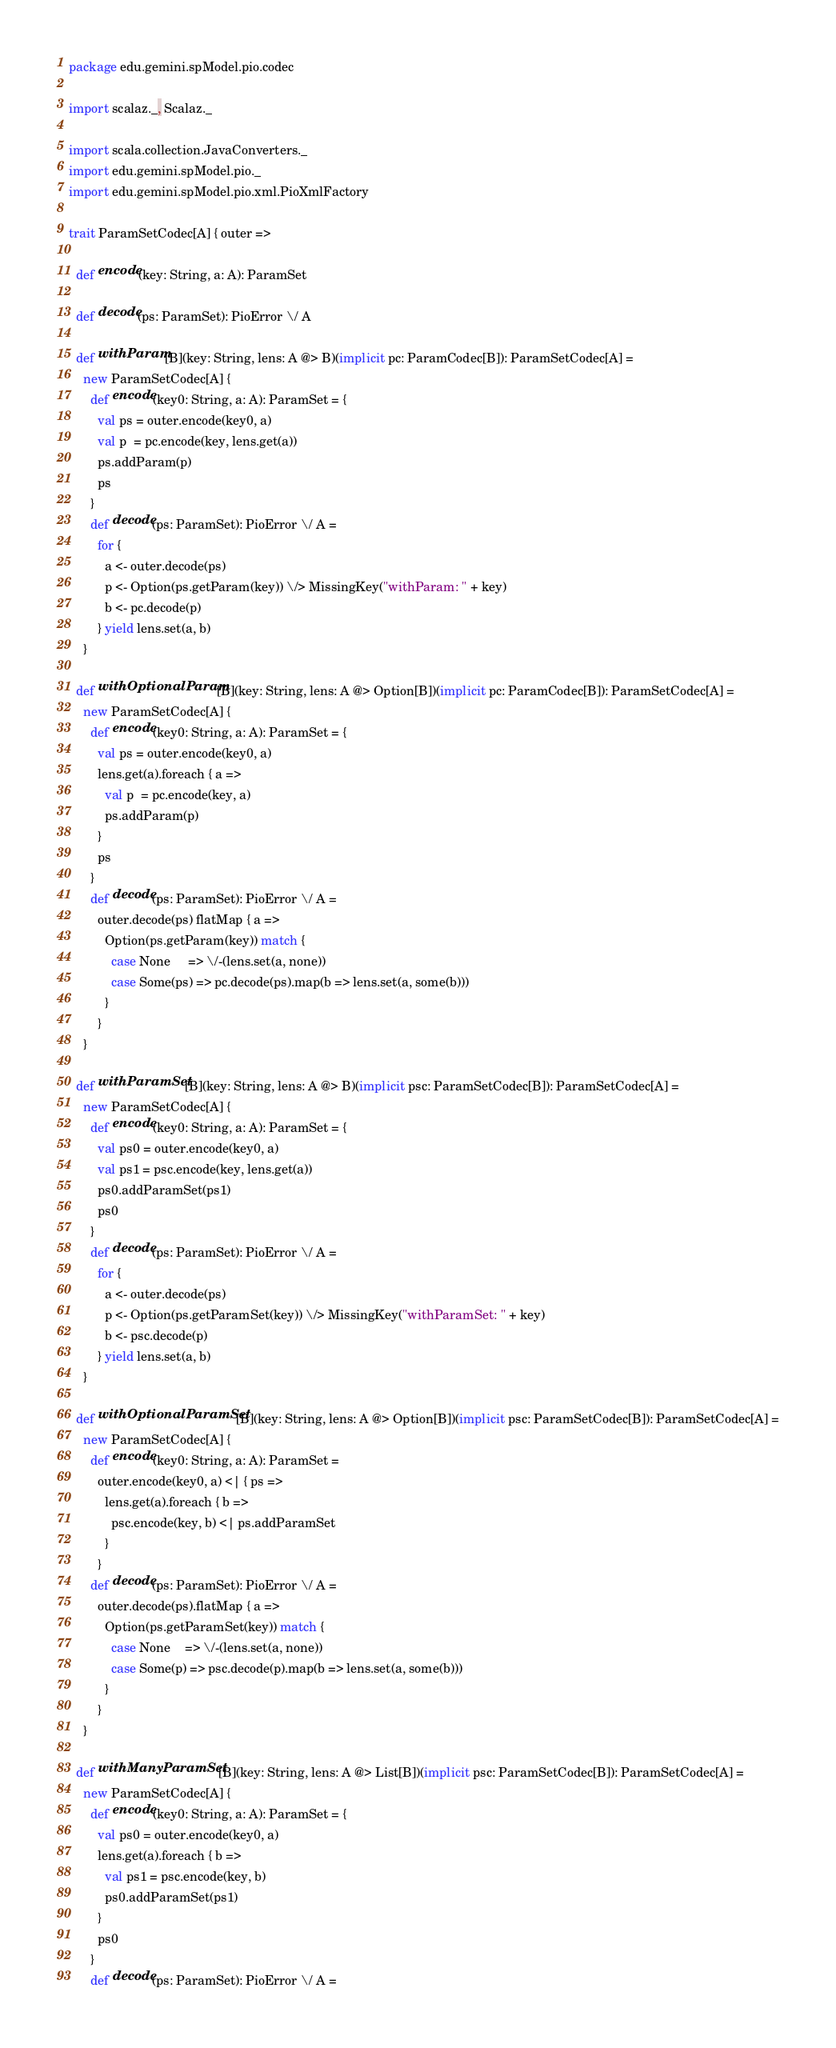<code> <loc_0><loc_0><loc_500><loc_500><_Scala_>package edu.gemini.spModel.pio.codec

import scalaz._, Scalaz._

import scala.collection.JavaConverters._
import edu.gemini.spModel.pio._
import edu.gemini.spModel.pio.xml.PioXmlFactory

trait ParamSetCodec[A] { outer =>
  
  def encode(key: String, a: A): ParamSet
  
  def decode(ps: ParamSet): PioError \/ A

  def withParam[B](key: String, lens: A @> B)(implicit pc: ParamCodec[B]): ParamSetCodec[A] =
    new ParamSetCodec[A] {
      def encode(key0: String, a: A): ParamSet = {
        val ps = outer.encode(key0, a)
        val p  = pc.encode(key, lens.get(a))
        ps.addParam(p)
        ps
      }
      def decode(ps: ParamSet): PioError \/ A =
        for {
          a <- outer.decode(ps)
          p <- Option(ps.getParam(key)) \/> MissingKey("withParam: " + key)
          b <- pc.decode(p)
        } yield lens.set(a, b)
    }

  def withOptionalParam[B](key: String, lens: A @> Option[B])(implicit pc: ParamCodec[B]): ParamSetCodec[A] =
    new ParamSetCodec[A] {
      def encode(key0: String, a: A): ParamSet = {
        val ps = outer.encode(key0, a)
        lens.get(a).foreach { a =>
          val p  = pc.encode(key, a)
          ps.addParam(p)
        }
        ps
      }
      def decode(ps: ParamSet): PioError \/ A =
        outer.decode(ps) flatMap { a =>
          Option(ps.getParam(key)) match {
            case None     => \/-(lens.set(a, none))
            case Some(ps) => pc.decode(ps).map(b => lens.set(a, some(b)))
          }
        }
    }

  def withParamSet[B](key: String, lens: A @> B)(implicit psc: ParamSetCodec[B]): ParamSetCodec[A] =
    new ParamSetCodec[A] {
      def encode(key0: String, a: A): ParamSet = {
        val ps0 = outer.encode(key0, a)
        val ps1 = psc.encode(key, lens.get(a))
        ps0.addParamSet(ps1)
        ps0
      }
      def decode(ps: ParamSet): PioError \/ A =
        for {
          a <- outer.decode(ps)
          p <- Option(ps.getParamSet(key)) \/> MissingKey("withParamSet: " + key)
          b <- psc.decode(p)
        } yield lens.set(a, b)
    }

  def withOptionalParamSet[B](key: String, lens: A @> Option[B])(implicit psc: ParamSetCodec[B]): ParamSetCodec[A] =
    new ParamSetCodec[A] {
      def encode(key0: String, a: A): ParamSet =
        outer.encode(key0, a) <| { ps => 
          lens.get(a).foreach { b =>
            psc.encode(key, b) <| ps.addParamSet
          }
        }
      def decode(ps: ParamSet): PioError \/ A =
        outer.decode(ps).flatMap { a =>
          Option(ps.getParamSet(key)) match {
            case None    => \/-(lens.set(a, none))
            case Some(p) => psc.decode(p).map(b => lens.set(a, some(b)))
          }
        }
    }

  def withManyParamSet[B](key: String, lens: A @> List[B])(implicit psc: ParamSetCodec[B]): ParamSetCodec[A] =
    new ParamSetCodec[A] {
      def encode(key0: String, a: A): ParamSet = {
        val ps0 = outer.encode(key0, a)
        lens.get(a).foreach { b =>
          val ps1 = psc.encode(key, b)
          ps0.addParamSet(ps1)
        }
        ps0
      }
      def decode(ps: ParamSet): PioError \/ A =</code> 